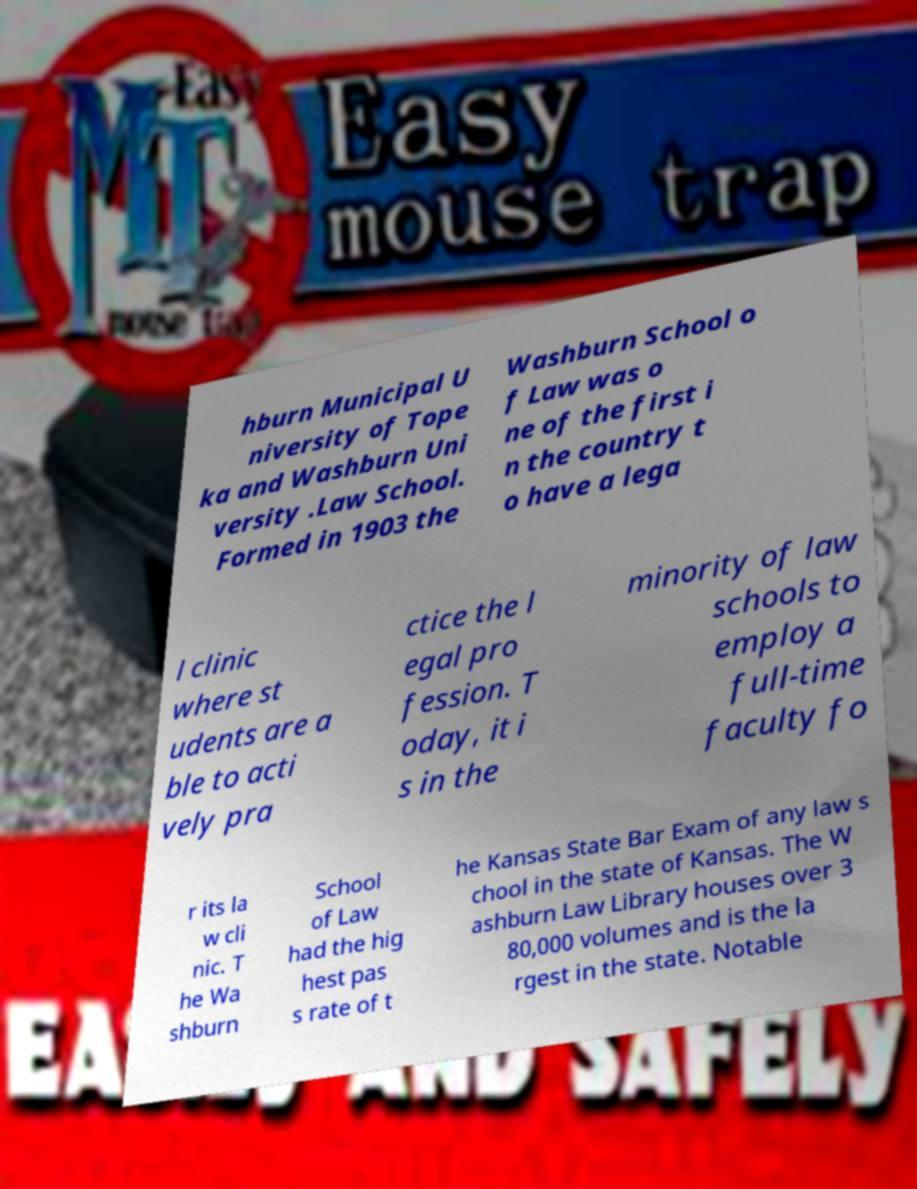What messages or text are displayed in this image? I need them in a readable, typed format. hburn Municipal U niversity of Tope ka and Washburn Uni versity .Law School. Formed in 1903 the Washburn School o f Law was o ne of the first i n the country t o have a lega l clinic where st udents are a ble to acti vely pra ctice the l egal pro fession. T oday, it i s in the minority of law schools to employ a full-time faculty fo r its la w cli nic. T he Wa shburn School of Law had the hig hest pas s rate of t he Kansas State Bar Exam of any law s chool in the state of Kansas. The W ashburn Law Library houses over 3 80,000 volumes and is the la rgest in the state. Notable 